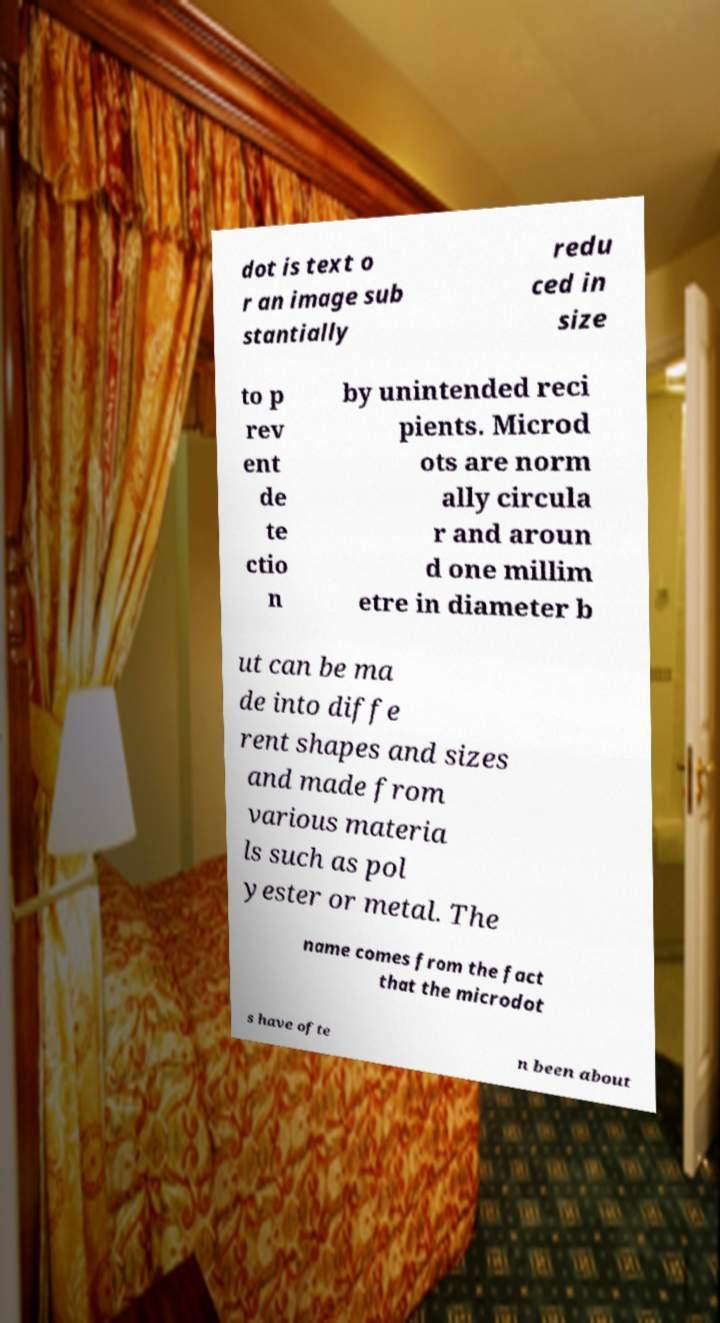Please identify and transcribe the text found in this image. dot is text o r an image sub stantially redu ced in size to p rev ent de te ctio n by unintended reci pients. Microd ots are norm ally circula r and aroun d one millim etre in diameter b ut can be ma de into diffe rent shapes and sizes and made from various materia ls such as pol yester or metal. The name comes from the fact that the microdot s have ofte n been about 